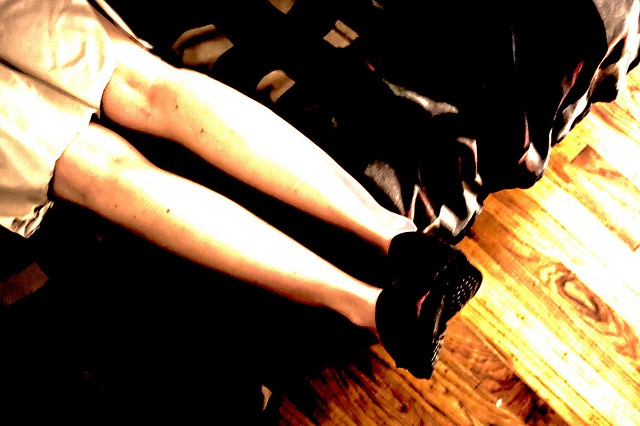Describe the objects in this image and their specific colors. I can see bed in tan, black, maroon, ivory, and gray tones and people in tan, ivory, black, khaki, and orange tones in this image. 